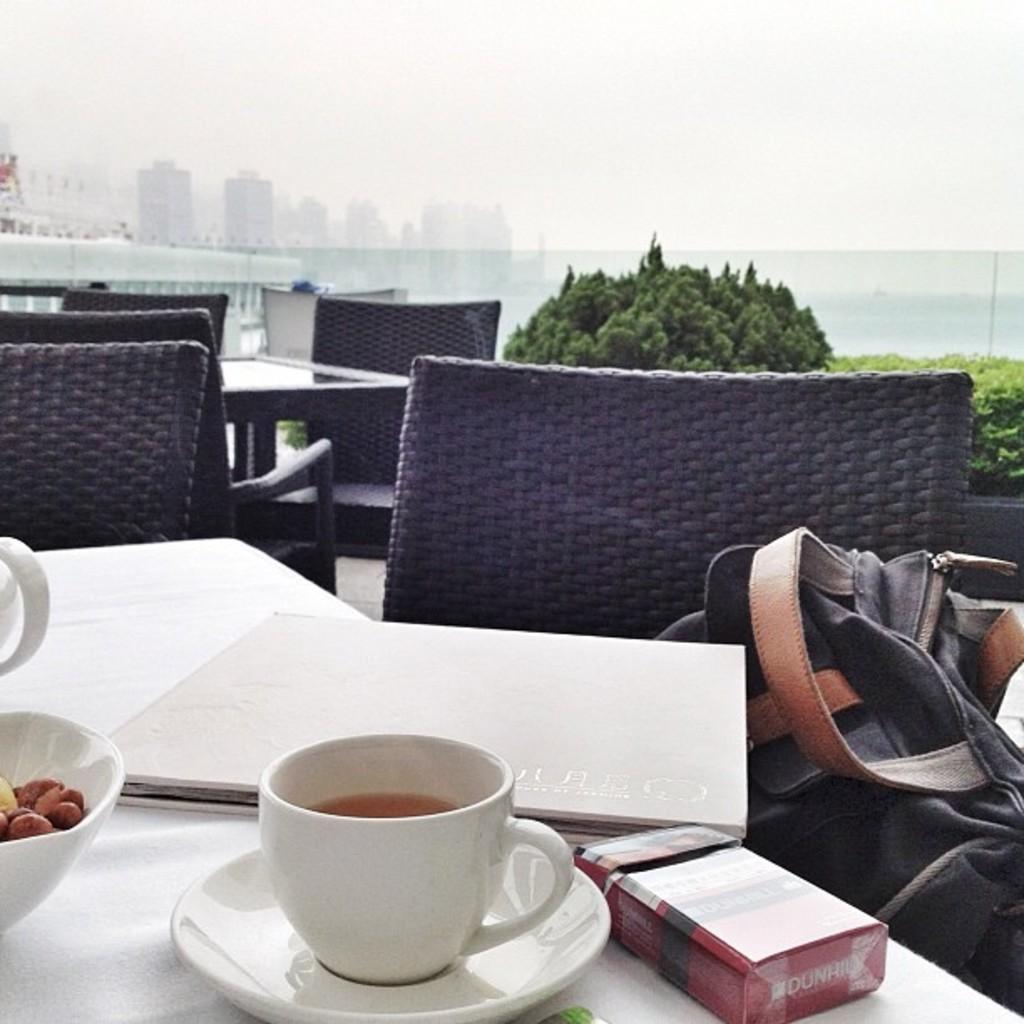Can you describe this image briefly? This is a table covered with white cloth. I can see a book,cup and saucer,bowl and red color object placed on the table. This is the bag kept on the chair. I can see few empty chairs and table here. These are the small bushes. At background I can see buildings. 